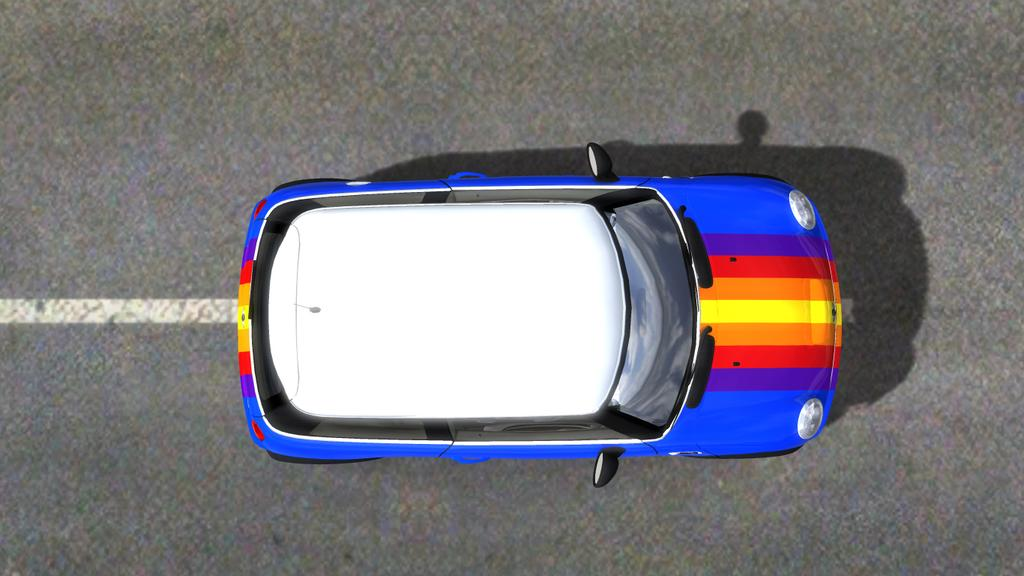What is the main subject of the image? The main subject of the image is a car. Where is the car located in the image? The car is on a road in the image. What type of boundary can be seen surrounding the car in the image? There is no boundary surrounding the car in the image. What kind of animal is visible near the car in the image? There are no animals present in the image; it only features a car on a road. 